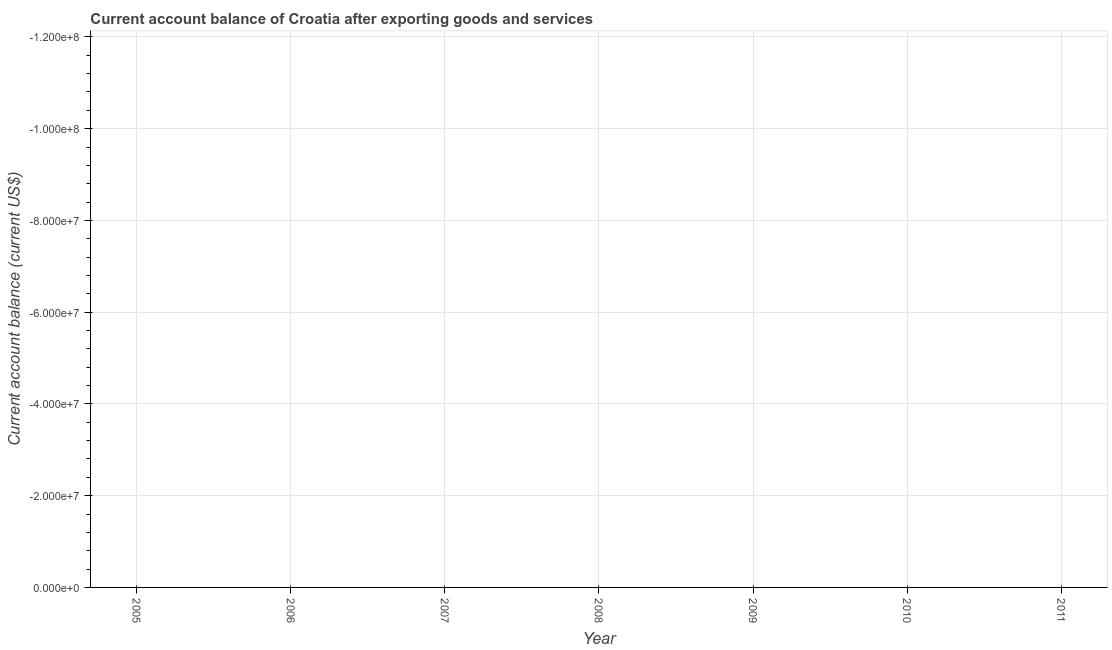Across all years, what is the minimum current account balance?
Your answer should be very brief. 0. What is the sum of the current account balance?
Make the answer very short. 0. What is the average current account balance per year?
Make the answer very short. 0. What is the median current account balance?
Make the answer very short. 0. Does the current account balance monotonically increase over the years?
Ensure brevity in your answer.  No. How many dotlines are there?
Your response must be concise. 0. How many years are there in the graph?
Give a very brief answer. 7. What is the difference between two consecutive major ticks on the Y-axis?
Your answer should be compact. 2.00e+07. Does the graph contain any zero values?
Keep it short and to the point. Yes. Does the graph contain grids?
Your answer should be compact. Yes. What is the title of the graph?
Provide a short and direct response. Current account balance of Croatia after exporting goods and services. What is the label or title of the Y-axis?
Make the answer very short. Current account balance (current US$). What is the Current account balance (current US$) in 2005?
Keep it short and to the point. 0. What is the Current account balance (current US$) in 2007?
Offer a terse response. 0. What is the Current account balance (current US$) in 2008?
Keep it short and to the point. 0. What is the Current account balance (current US$) in 2010?
Make the answer very short. 0. 